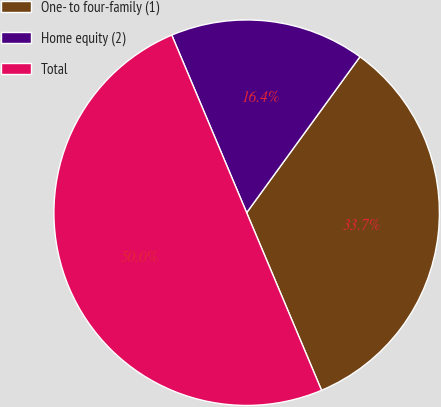Convert chart to OTSL. <chart><loc_0><loc_0><loc_500><loc_500><pie_chart><fcel>One- to four-family (1)<fcel>Home equity (2)<fcel>Total<nl><fcel>33.65%<fcel>16.35%<fcel>50.0%<nl></chart> 